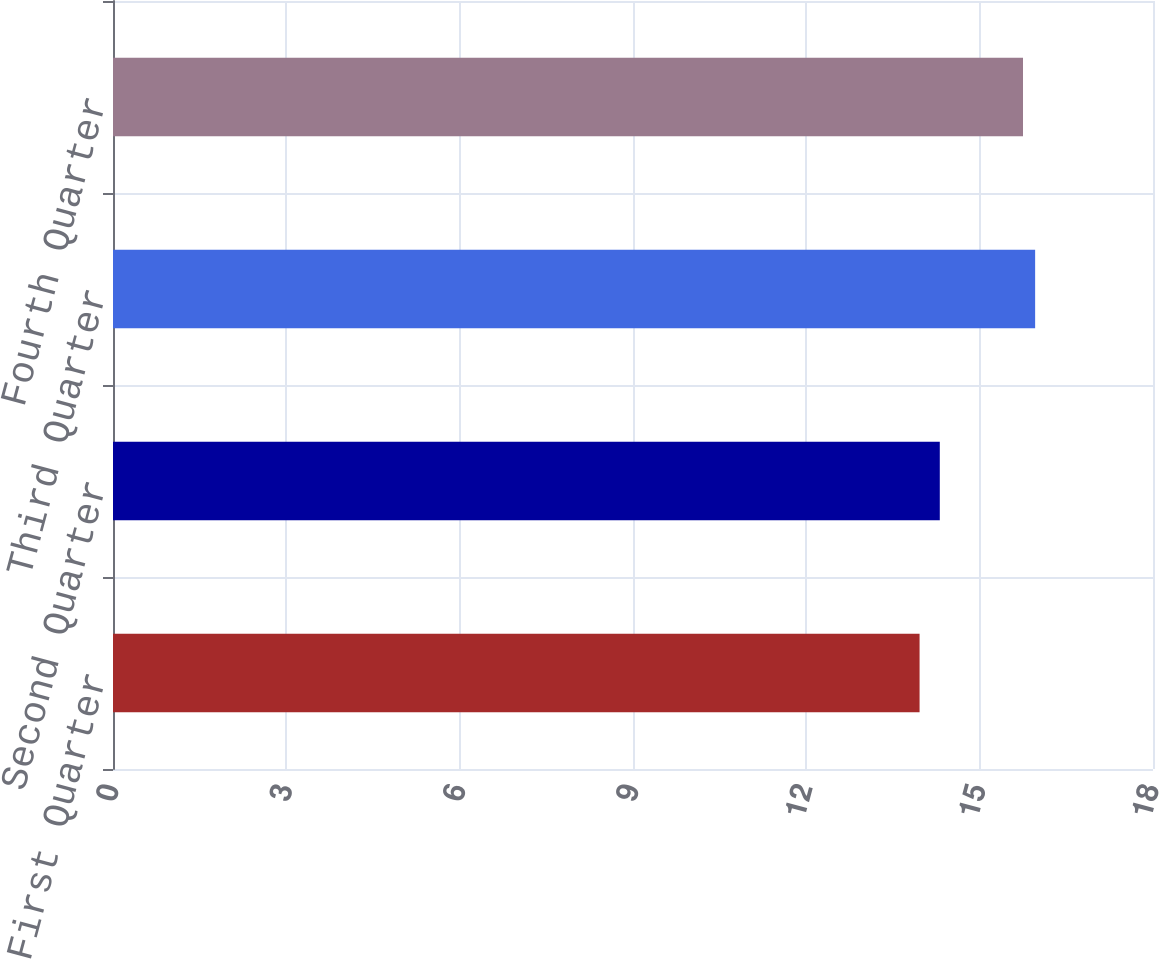<chart> <loc_0><loc_0><loc_500><loc_500><bar_chart><fcel>First Quarter<fcel>Second Quarter<fcel>Third Quarter<fcel>Fourth Quarter<nl><fcel>13.96<fcel>14.31<fcel>15.96<fcel>15.75<nl></chart> 